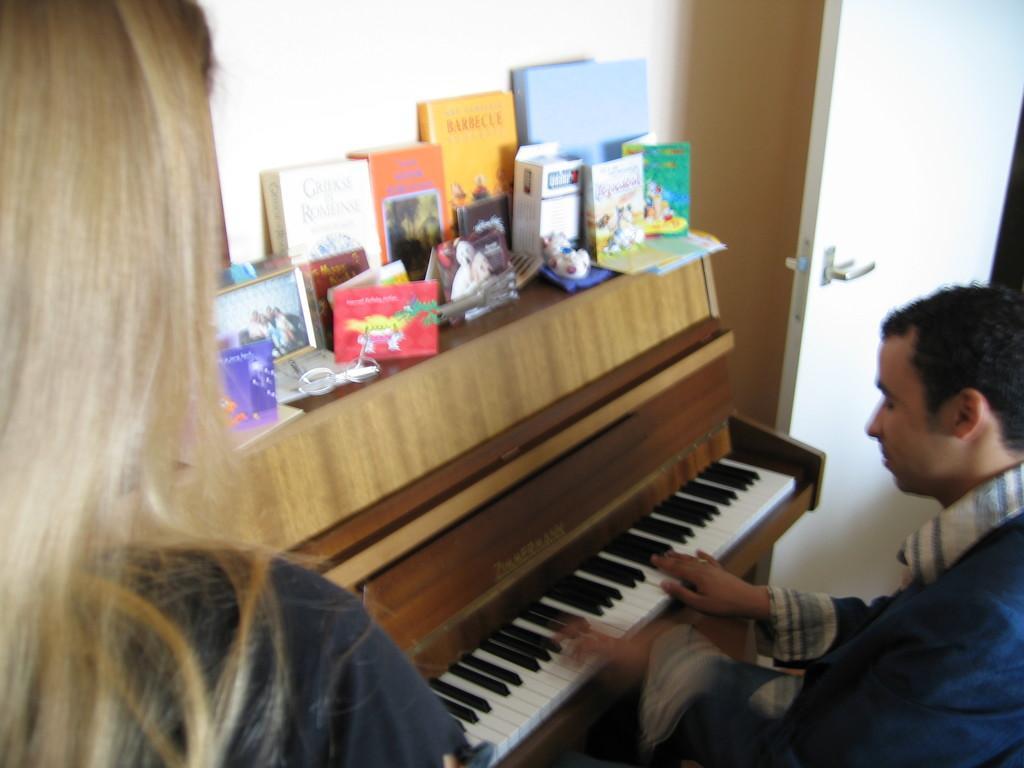Describe this image in one or two sentences. These are the books,photo frames and some objects placed on the table. Here is a man sitting and playing piano. This is the door with a door handle. This is the woman standing. 